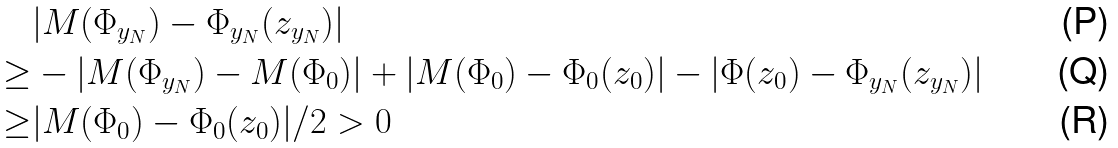<formula> <loc_0><loc_0><loc_500><loc_500>& | M ( \Phi _ { y _ { N } } ) - \Phi _ { y _ { N } } ( z _ { y _ { N } } ) | \\ \geq & - | M ( \Phi _ { y _ { N } } ) - M ( \Phi _ { 0 } ) | + | M ( \Phi _ { 0 } ) - \Phi _ { 0 } ( z _ { 0 } ) | - | \Phi ( z _ { 0 } ) - \Phi _ { y _ { N } } ( z _ { y _ { N } } ) | \\ \geq & | M ( \Phi _ { 0 } ) - \Phi _ { 0 } ( z _ { 0 } ) | / 2 > 0</formula> 